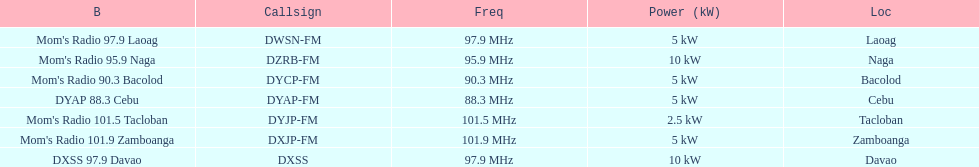What are the total number of radio stations on this list? 7. 